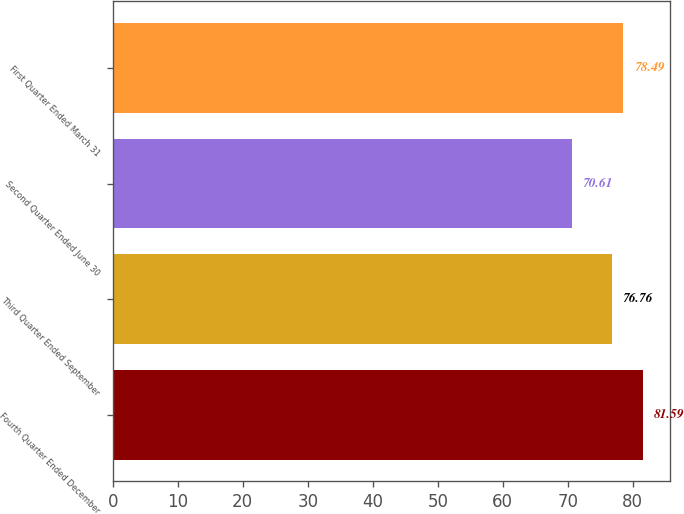<chart> <loc_0><loc_0><loc_500><loc_500><bar_chart><fcel>Fourth Quarter Ended December<fcel>Third Quarter Ended September<fcel>Second Quarter Ended June 30<fcel>First Quarter Ended March 31<nl><fcel>81.59<fcel>76.76<fcel>70.61<fcel>78.49<nl></chart> 